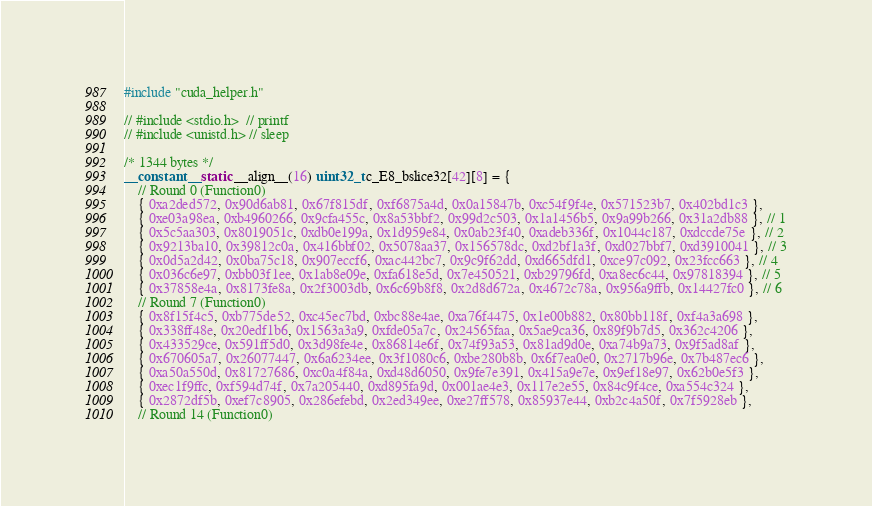Convert code to text. <code><loc_0><loc_0><loc_500><loc_500><_Cuda_>#include "cuda_helper.h"

// #include <stdio.h>  // printf
// #include <unistd.h> // sleep

/* 1344 bytes */
__constant__ static __align__(16) uint32_t c_E8_bslice32[42][8] = {
	// Round 0 (Function0)
	{ 0xa2ded572, 0x90d6ab81, 0x67f815df, 0xf6875a4d, 0x0a15847b, 0xc54f9f4e, 0x571523b7, 0x402bd1c3 },
	{ 0xe03a98ea, 0xb4960266, 0x9cfa455c, 0x8a53bbf2, 0x99d2c503, 0x1a1456b5, 0x9a99b266, 0x31a2db88 }, // 1
	{ 0x5c5aa303, 0x8019051c, 0xdb0e199a, 0x1d959e84, 0x0ab23f40, 0xadeb336f, 0x1044c187, 0xdccde75e }, // 2
	{ 0x9213ba10, 0x39812c0a, 0x416bbf02, 0x5078aa37, 0x156578dc, 0xd2bf1a3f, 0xd027bbf7, 0xd3910041 }, // 3
	{ 0x0d5a2d42, 0x0ba75c18, 0x907eccf6, 0xac442bc7, 0x9c9f62dd, 0xd665dfd1, 0xce97c092, 0x23fcc663 }, // 4
	{ 0x036c6e97, 0xbb03f1ee, 0x1ab8e09e, 0xfa618e5d, 0x7e450521, 0xb29796fd, 0xa8ec6c44, 0x97818394 }, // 5
	{ 0x37858e4a, 0x8173fe8a, 0x2f3003db, 0x6c69b8f8, 0x2d8d672a, 0x4672c78a, 0x956a9ffb, 0x14427fc0 }, // 6
	// Round 7 (Function0)
	{ 0x8f15f4c5, 0xb775de52, 0xc45ec7bd, 0xbc88e4ae, 0xa76f4475, 0x1e00b882, 0x80bb118f, 0xf4a3a698 },
	{ 0x338ff48e, 0x20edf1b6, 0x1563a3a9, 0xfde05a7c, 0x24565faa, 0x5ae9ca36, 0x89f9b7d5, 0x362c4206 },
	{ 0x433529ce, 0x591ff5d0, 0x3d98fe4e, 0x86814e6f, 0x74f93a53, 0x81ad9d0e, 0xa74b9a73, 0x9f5ad8af },
	{ 0x670605a7, 0x26077447, 0x6a6234ee, 0x3f1080c6, 0xbe280b8b, 0x6f7ea0e0, 0x2717b96e, 0x7b487ec6 },
	{ 0xa50a550d, 0x81727686, 0xc0a4f84a, 0xd48d6050, 0x9fe7e391, 0x415a9e7e, 0x9ef18e97, 0x62b0e5f3 },
	{ 0xec1f9ffc, 0xf594d74f, 0x7a205440, 0xd895fa9d, 0x001ae4e3, 0x117e2e55, 0x84c9f4ce, 0xa554c324 },
	{ 0x2872df5b, 0xef7c8905, 0x286efebd, 0x2ed349ee, 0xe27ff578, 0x85937e44, 0xb2c4a50f, 0x7f5928eb },
	// Round 14 (Function0)</code> 